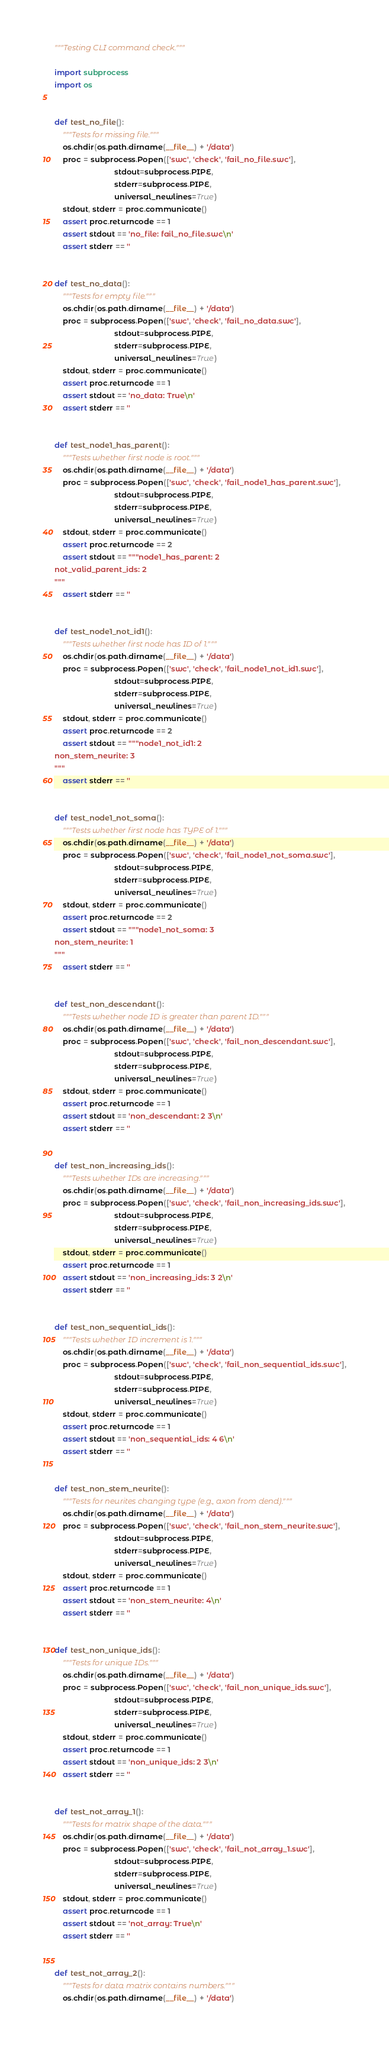<code> <loc_0><loc_0><loc_500><loc_500><_Python_>"""Testing CLI command check."""

import subprocess
import os


def test_no_file():
    """Tests for missing file."""
    os.chdir(os.path.dirname(__file__) + '/data')
    proc = subprocess.Popen(['swc', 'check', 'fail_no_file.swc'],
                            stdout=subprocess.PIPE,
                            stderr=subprocess.PIPE,
                            universal_newlines=True)
    stdout, stderr = proc.communicate()
    assert proc.returncode == 1
    assert stdout == 'no_file: fail_no_file.swc\n'
    assert stderr == ''


def test_no_data():
    """Tests for empty file."""
    os.chdir(os.path.dirname(__file__) + '/data')
    proc = subprocess.Popen(['swc', 'check', 'fail_no_data.swc'],
                            stdout=subprocess.PIPE,
                            stderr=subprocess.PIPE,
                            universal_newlines=True)
    stdout, stderr = proc.communicate()
    assert proc.returncode == 1
    assert stdout == 'no_data: True\n'
    assert stderr == ''


def test_node1_has_parent():
    """Tests whether first node is root."""
    os.chdir(os.path.dirname(__file__) + '/data')
    proc = subprocess.Popen(['swc', 'check', 'fail_node1_has_parent.swc'],
                            stdout=subprocess.PIPE,
                            stderr=subprocess.PIPE,
                            universal_newlines=True)
    stdout, stderr = proc.communicate()
    assert proc.returncode == 2
    assert stdout == """node1_has_parent: 2
not_valid_parent_ids: 2
"""
    assert stderr == ''


def test_node1_not_id1():
    """Tests whether first node has ID of 1."""
    os.chdir(os.path.dirname(__file__) + '/data')
    proc = subprocess.Popen(['swc', 'check', 'fail_node1_not_id1.swc'],
                            stdout=subprocess.PIPE,
                            stderr=subprocess.PIPE,
                            universal_newlines=True)
    stdout, stderr = proc.communicate()
    assert proc.returncode == 2
    assert stdout == """node1_not_id1: 2
non_stem_neurite: 3
"""
    assert stderr == ''


def test_node1_not_soma():
    """Tests whether first node has TYPE of 1."""
    os.chdir(os.path.dirname(__file__) + '/data')
    proc = subprocess.Popen(['swc', 'check', 'fail_node1_not_soma.swc'],
                            stdout=subprocess.PIPE,
                            stderr=subprocess.PIPE,
                            universal_newlines=True)
    stdout, stderr = proc.communicate()
    assert proc.returncode == 2
    assert stdout == """node1_not_soma: 3
non_stem_neurite: 1
"""
    assert stderr == ''


def test_non_descendant():
    """Tests whether node ID is greater than parent ID."""
    os.chdir(os.path.dirname(__file__) + '/data')
    proc = subprocess.Popen(['swc', 'check', 'fail_non_descendant.swc'],
                            stdout=subprocess.PIPE,
                            stderr=subprocess.PIPE,
                            universal_newlines=True)
    stdout, stderr = proc.communicate()
    assert proc.returncode == 1
    assert stdout == 'non_descendant: 2 3\n'
    assert stderr == ''


def test_non_increasing_ids():
    """Tests whether IDs are increasing."""
    os.chdir(os.path.dirname(__file__) + '/data')
    proc = subprocess.Popen(['swc', 'check', 'fail_non_increasing_ids.swc'],
                            stdout=subprocess.PIPE,
                            stderr=subprocess.PIPE,
                            universal_newlines=True)
    stdout, stderr = proc.communicate()
    assert proc.returncode == 1
    assert stdout == 'non_increasing_ids: 3 2\n'
    assert stderr == ''


def test_non_sequential_ids():
    """Tests whether ID increment is 1."""
    os.chdir(os.path.dirname(__file__) + '/data')
    proc = subprocess.Popen(['swc', 'check', 'fail_non_sequential_ids.swc'],
                            stdout=subprocess.PIPE,
                            stderr=subprocess.PIPE,
                            universal_newlines=True)
    stdout, stderr = proc.communicate()
    assert proc.returncode == 1
    assert stdout == 'non_sequential_ids: 4 6\n'
    assert stderr == ''


def test_non_stem_neurite():
    """Tests for neurites changing type (e.g., axon from dend)."""
    os.chdir(os.path.dirname(__file__) + '/data')
    proc = subprocess.Popen(['swc', 'check', 'fail_non_stem_neurite.swc'],
                            stdout=subprocess.PIPE,
                            stderr=subprocess.PIPE,
                            universal_newlines=True)
    stdout, stderr = proc.communicate()
    assert proc.returncode == 1
    assert stdout == 'non_stem_neurite: 4\n'
    assert stderr == ''


def test_non_unique_ids():
    """Tests for unique IDs."""
    os.chdir(os.path.dirname(__file__) + '/data')
    proc = subprocess.Popen(['swc', 'check', 'fail_non_unique_ids.swc'],
                            stdout=subprocess.PIPE,
                            stderr=subprocess.PIPE,
                            universal_newlines=True)
    stdout, stderr = proc.communicate()
    assert proc.returncode == 1
    assert stdout == 'non_unique_ids: 2 3\n'
    assert stderr == ''


def test_not_array_1():
    """Tests for matrix shape of the data."""
    os.chdir(os.path.dirname(__file__) + '/data')
    proc = subprocess.Popen(['swc', 'check', 'fail_not_array_1.swc'],
                            stdout=subprocess.PIPE,
                            stderr=subprocess.PIPE,
                            universal_newlines=True)
    stdout, stderr = proc.communicate()
    assert proc.returncode == 1
    assert stdout == 'not_array: True\n'
    assert stderr == ''


def test_not_array_2():
    """Tests for data matrix contains numbers."""
    os.chdir(os.path.dirname(__file__) + '/data')</code> 